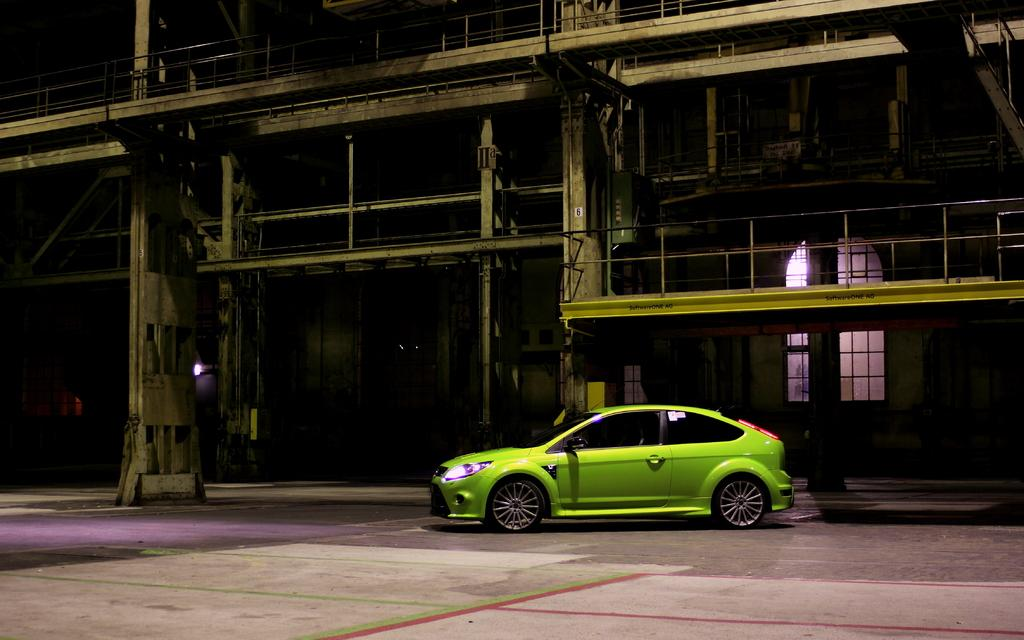What is the main subject in the center of the image? There is a green car in the center of the image. What can be seen in the background of the image? There is a building, light, a fence, a window, and poles visible in the background of the image. What type of spark can be seen coming from the car in the image? There is no spark visible in the image; the car appears to be stationary. 